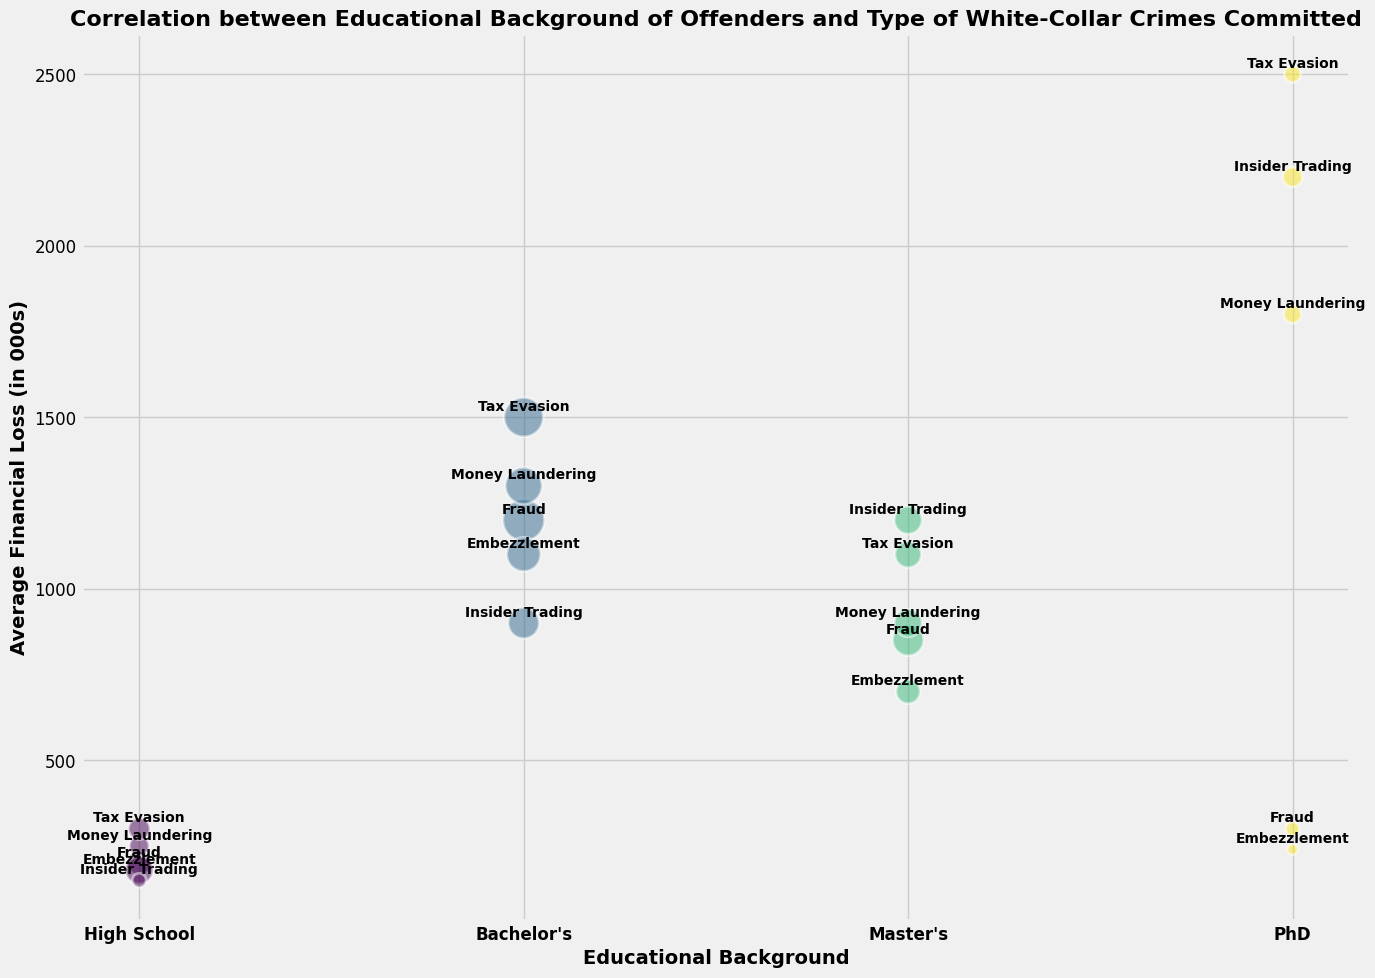what's the average financial loss for offenders with a Bachelor's degree? To find the average financial loss for offenders with a Bachelor's degree, identify the data points corresponding to "Bachelor's" for each crime type. The data points are: Fraud (1200), Embezzlement (1100), Insider Trading (900), Money Laundering (1300), Tax Evasion (1500). Calculate the average by summing these values (1200 + 1100 + 900 + 1300 + 1500 = 6000) and dividing by the number of data points (5). The average financial loss is 6000 / 5 = 1200.
Answer: 1200 which crime type associated with PhD offenders leads to the highest average financial loss? Look at the data points for PhD offenders and find the highest average financial loss among the crime types. The data points are: Fraud (300), Embezzlement (240), Insider Trading (2200), Money Laundering (1800), Tax Evasion (2500). The highest average financial loss is from Tax Evasion (2500).
Answer: Tax Evasion which educational background has the highest number of offenders for Money Laundering? Identify the number of offenders for Money Laundering across different educational backgrounds: High School (10), Bachelor's (35), Master's (20), PhD (8). The highest number of offenders is for Bachelor's (35).
Answer: Bachelor's is the average financial loss for Insider Trading higher with a Master's degree or a Bachelor's degree? Identify the average financial loss for Insider Trading with a Master's degree (1200) and a Bachelor's degree (900). Compare the two values. Since 1200 > 900, the average financial loss is higher with a Master's degree.
Answer: Master's how does the average financial loss compare between PhD offenders and High School offenders for Tax Evasion? Identify the average financial loss for Tax Evasion for PhD offenders (2500) and High School offenders (300). Compare the two values. Since 2500 > 300, the average financial loss is higher for PhD offenders.
Answer: PhD which educational background and crime type combination has the smallest bubble size? The bubble size represents the number of offenders. Identify the smallest number: Fraud (High School, 15), Embezzlement (High School, 20), Insider Trading (High School, 5), Money Laundering (High School, 10), Tax Evasion (High School, 12), Fraud (PhD, 5), Embezzlement (PhD, 3), Insider Trading (PhD, 10), Money Laundering (PhD, 8), Tax Evasion (PhD, 7). The smallest bubble size is Embezzlement by PhD offenders (3).
Answer: Embezzlement, PhD do PhD offenders lead to higher average financial losses in Insider Trading or Money Laundering? Identify the average financial loss for PhD offenders in Insider Trading (2200) and Money Laundering (1800). Compare the two values. Since 2200 > 1800, PhD offenders lead to higher financial losses in Insider Trading.
Answer: Insider Trading what is the total number of offenders with a Master's degree across all crime types? Identify the number of offenders for each crime type with a Master’s degree: Fraud (25), Embezzlement (15), Insider Trading (20), Money Laundering (20), Tax Evasion (18). Sum these values: 25 + 15 + 20 + 20 + 18 = 98. The total number of offenders with a Master's degree is 98.
Answer: 98 